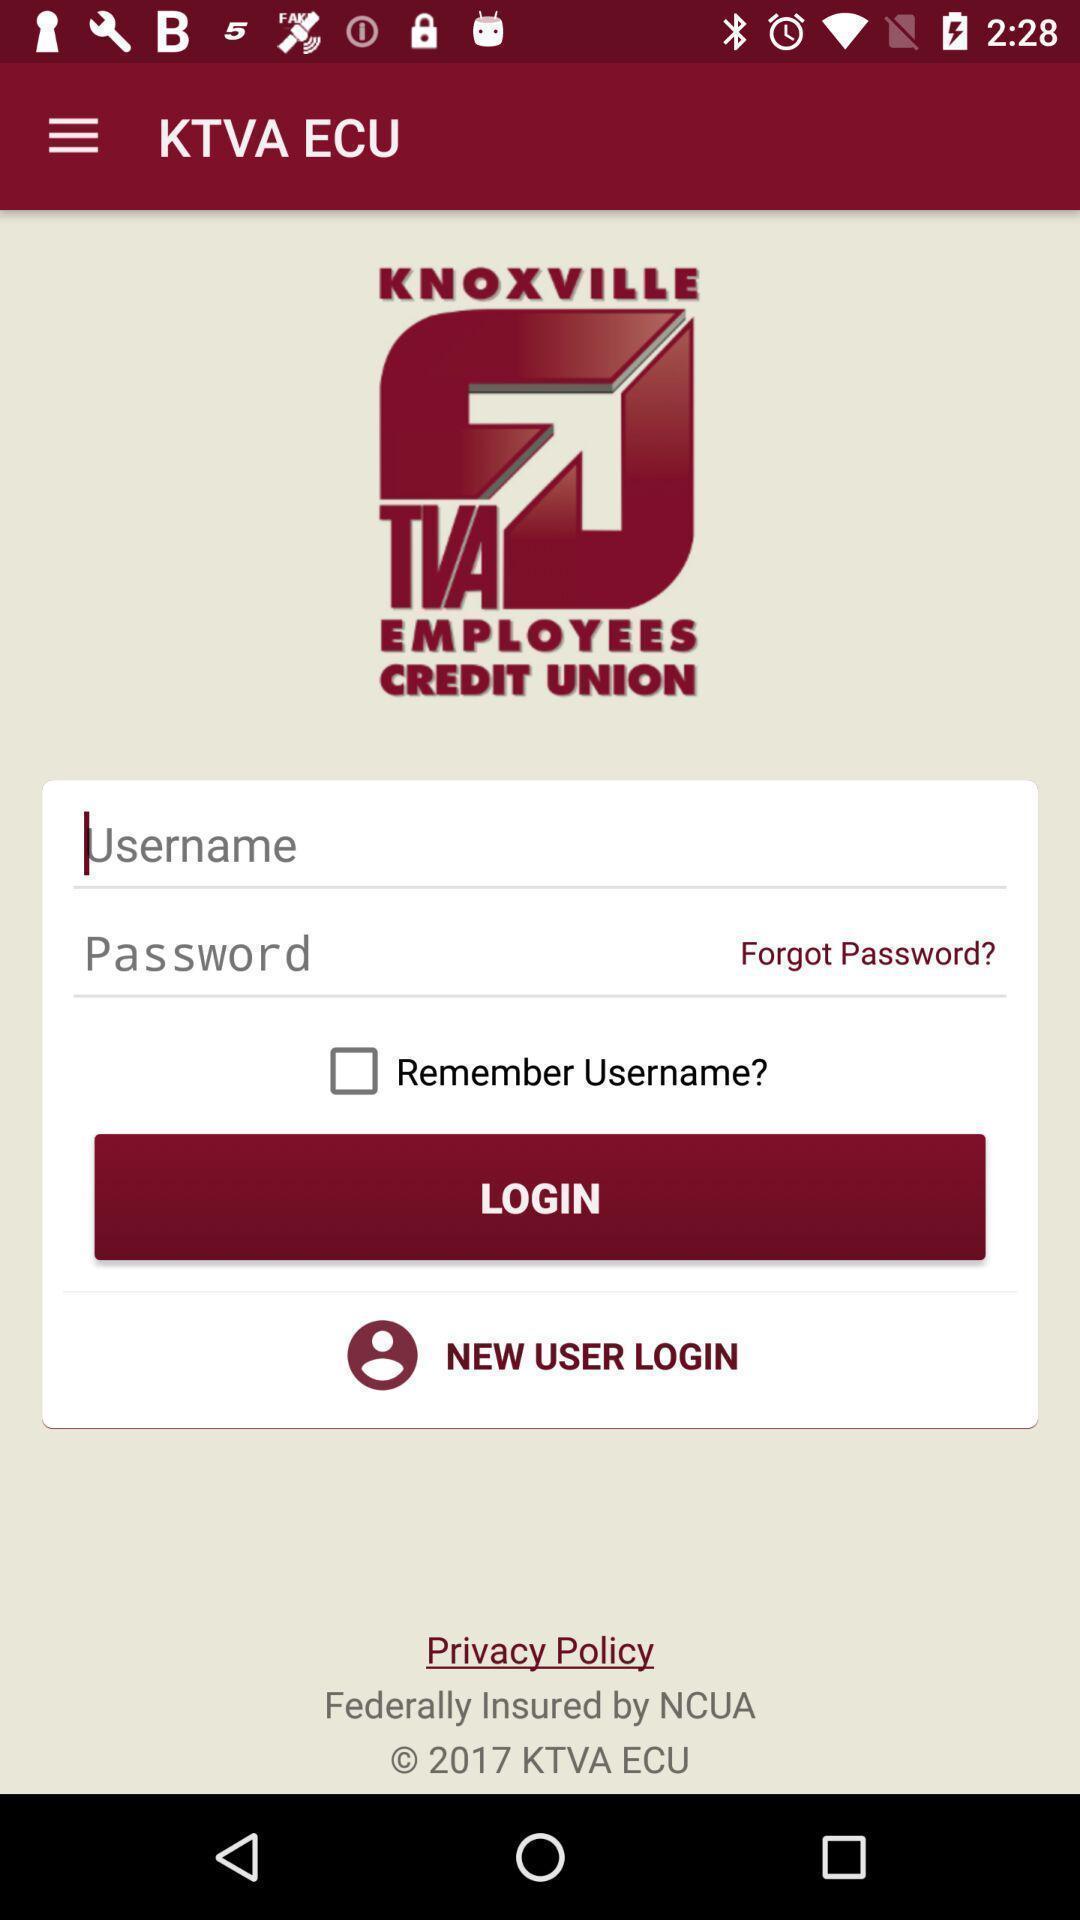What can you discern from this picture? Welcome and log-in page for an application. 